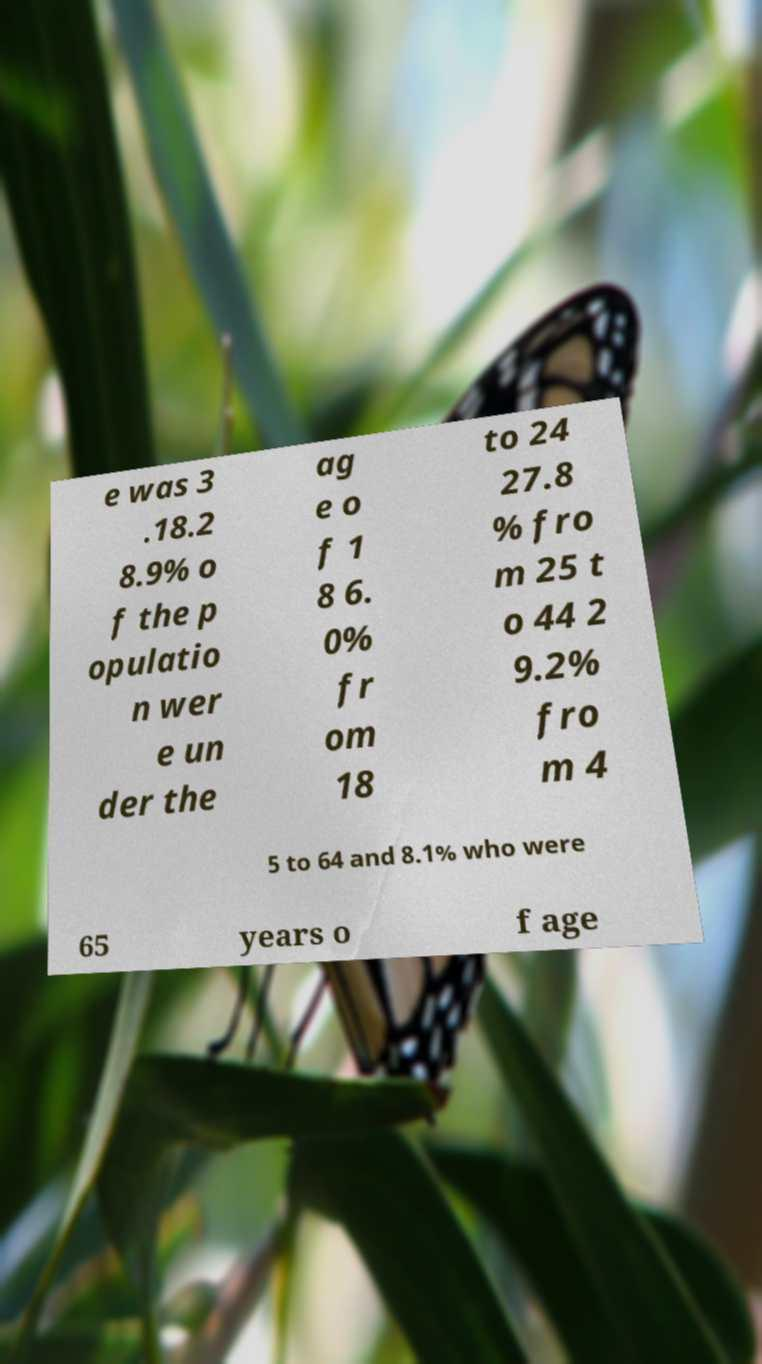There's text embedded in this image that I need extracted. Can you transcribe it verbatim? e was 3 .18.2 8.9% o f the p opulatio n wer e un der the ag e o f 1 8 6. 0% fr om 18 to 24 27.8 % fro m 25 t o 44 2 9.2% fro m 4 5 to 64 and 8.1% who were 65 years o f age 